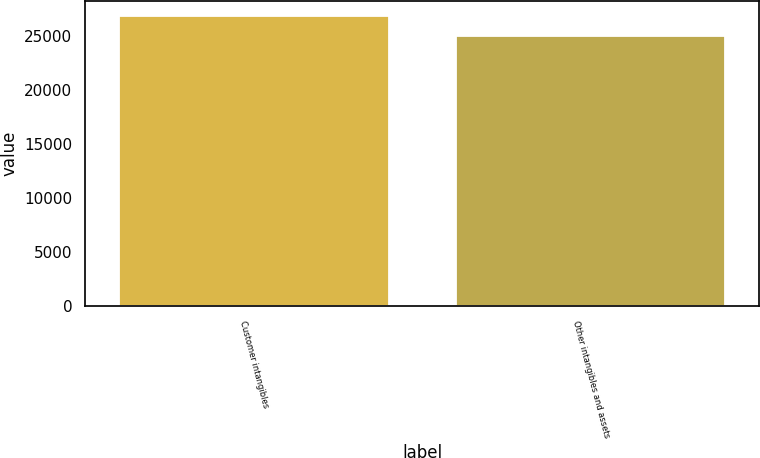Convert chart. <chart><loc_0><loc_0><loc_500><loc_500><bar_chart><fcel>Customer intangibles<fcel>Other intangibles and assets<nl><fcel>26866<fcel>25000<nl></chart> 